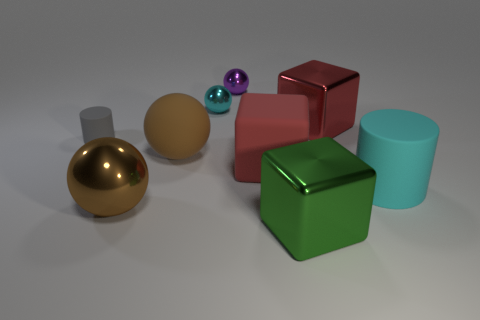The tiny purple thing that is made of the same material as the cyan sphere is what shape? The small purple object, sharing the same glossy texture as the larger cyan sphere, is also a sphere. 